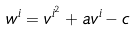<formula> <loc_0><loc_0><loc_500><loc_500>w ^ { i } = v ^ { i ^ { 2 } } + a v ^ { i } - c</formula> 